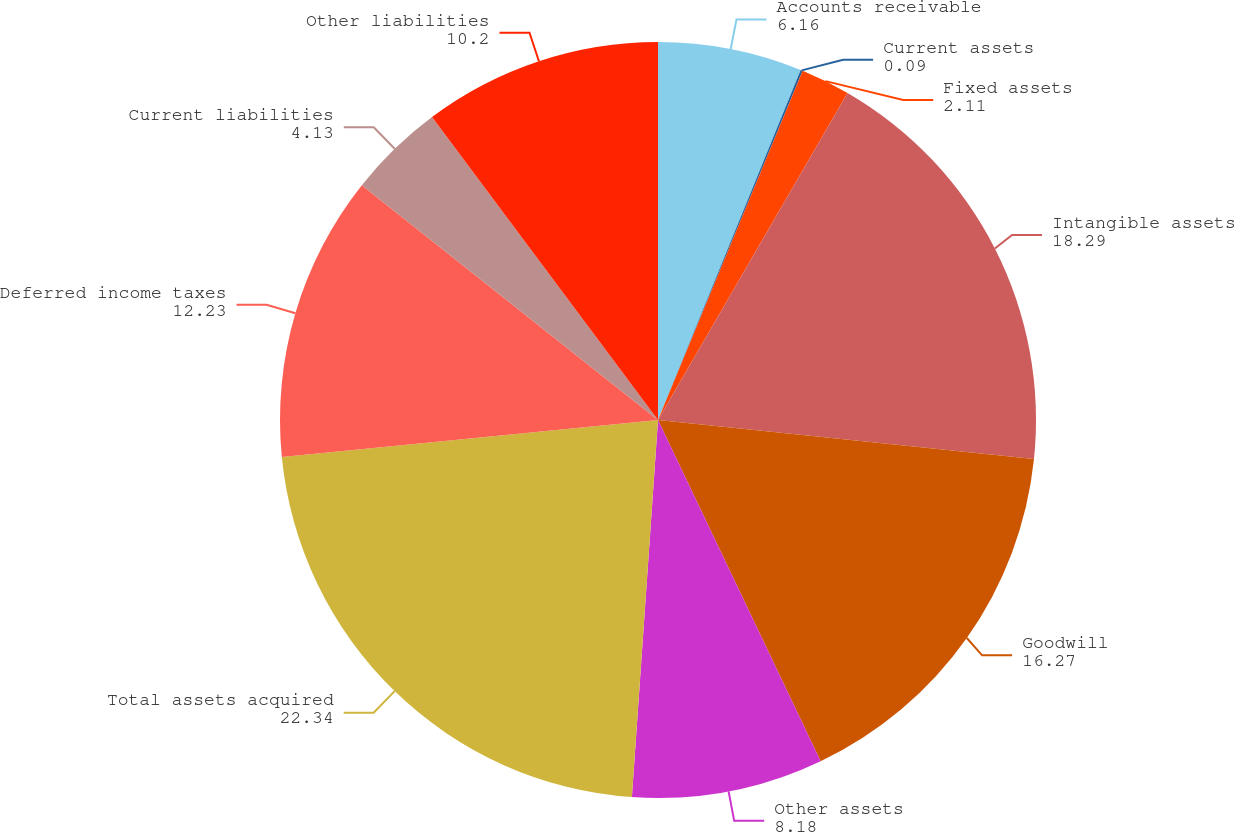<chart> <loc_0><loc_0><loc_500><loc_500><pie_chart><fcel>Accounts receivable<fcel>Current assets<fcel>Fixed assets<fcel>Intangible assets<fcel>Goodwill<fcel>Other assets<fcel>Total assets acquired<fcel>Deferred income taxes<fcel>Current liabilities<fcel>Other liabilities<nl><fcel>6.16%<fcel>0.09%<fcel>2.11%<fcel>18.29%<fcel>16.27%<fcel>8.18%<fcel>22.34%<fcel>12.23%<fcel>4.13%<fcel>10.2%<nl></chart> 